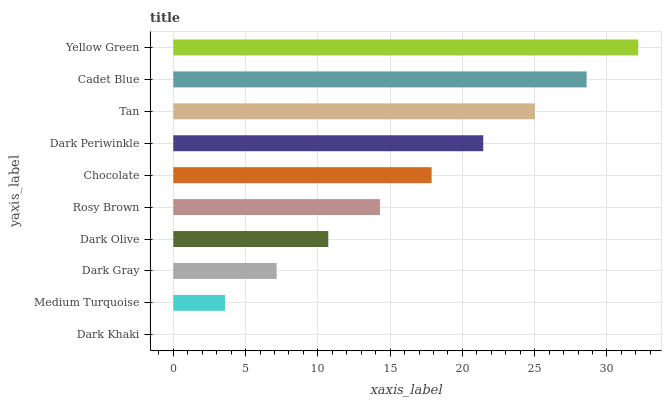Is Dark Khaki the minimum?
Answer yes or no. Yes. Is Yellow Green the maximum?
Answer yes or no. Yes. Is Medium Turquoise the minimum?
Answer yes or no. No. Is Medium Turquoise the maximum?
Answer yes or no. No. Is Medium Turquoise greater than Dark Khaki?
Answer yes or no. Yes. Is Dark Khaki less than Medium Turquoise?
Answer yes or no. Yes. Is Dark Khaki greater than Medium Turquoise?
Answer yes or no. No. Is Medium Turquoise less than Dark Khaki?
Answer yes or no. No. Is Chocolate the high median?
Answer yes or no. Yes. Is Rosy Brown the low median?
Answer yes or no. Yes. Is Dark Gray the high median?
Answer yes or no. No. Is Dark Gray the low median?
Answer yes or no. No. 